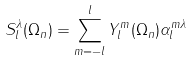Convert formula to latex. <formula><loc_0><loc_0><loc_500><loc_500>S ^ { \lambda } _ { l } ( \Omega _ { n } ) = \sum _ { m = - l } ^ { l } Y ^ { m } _ { l } ( \Omega _ { n } ) \alpha _ { l } ^ { m \lambda }</formula> 